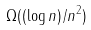Convert formula to latex. <formula><loc_0><loc_0><loc_500><loc_500>\Omega ( ( \log n ) / n ^ { 2 } )</formula> 